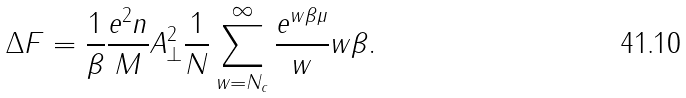Convert formula to latex. <formula><loc_0><loc_0><loc_500><loc_500>\Delta F = \frac { 1 } { \beta } \frac { e ^ { 2 } n } { M } A _ { \perp } ^ { 2 } \frac { 1 } { N } \sum _ { w = N _ { c } } ^ { \infty } \frac { e ^ { w \beta \mu } } { w } w \beta .</formula> 